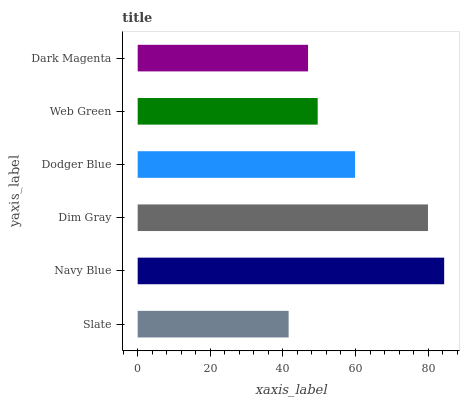Is Slate the minimum?
Answer yes or no. Yes. Is Navy Blue the maximum?
Answer yes or no. Yes. Is Dim Gray the minimum?
Answer yes or no. No. Is Dim Gray the maximum?
Answer yes or no. No. Is Navy Blue greater than Dim Gray?
Answer yes or no. Yes. Is Dim Gray less than Navy Blue?
Answer yes or no. Yes. Is Dim Gray greater than Navy Blue?
Answer yes or no. No. Is Navy Blue less than Dim Gray?
Answer yes or no. No. Is Dodger Blue the high median?
Answer yes or no. Yes. Is Web Green the low median?
Answer yes or no. Yes. Is Slate the high median?
Answer yes or no. No. Is Dodger Blue the low median?
Answer yes or no. No. 